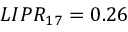<formula> <loc_0><loc_0><loc_500><loc_500>L I P R _ { 1 7 } = 0 . 2 6</formula> 